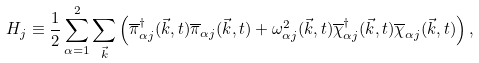Convert formula to latex. <formula><loc_0><loc_0><loc_500><loc_500>H _ { j } \equiv \frac { 1 } { 2 } \sum _ { { \alpha } = 1 } ^ { 2 } \sum _ { \vec { k } } \left ( \overline { \pi } _ { { \alpha } j } ^ { \dagger } ( \vec { k } , t ) \overline { \pi } _ { { \alpha } j } ( \vec { k } , t ) + { \omega } _ { { \alpha } j } ^ { 2 } ( \vec { k } , t ) \overline { \chi } _ { { \alpha } j } ^ { \dagger } ( \vec { k } , t ) \overline { \chi } _ { { \alpha } j } ( \vec { k } , t ) \right ) ,</formula> 